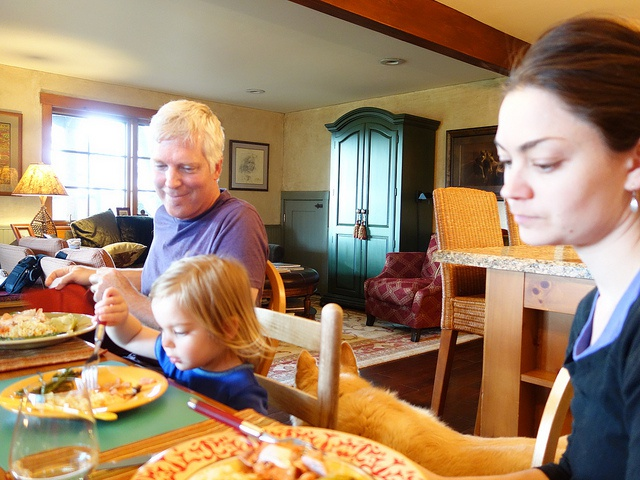Describe the objects in this image and their specific colors. I can see people in darkgray, lightgray, black, navy, and lightpink tones, dining table in darkgray, orange, khaki, and gold tones, people in darkgray, white, brown, and tan tones, dining table in darkgray, red, tan, and maroon tones, and people in darkgray, brown, lightgray, tan, and black tones in this image. 